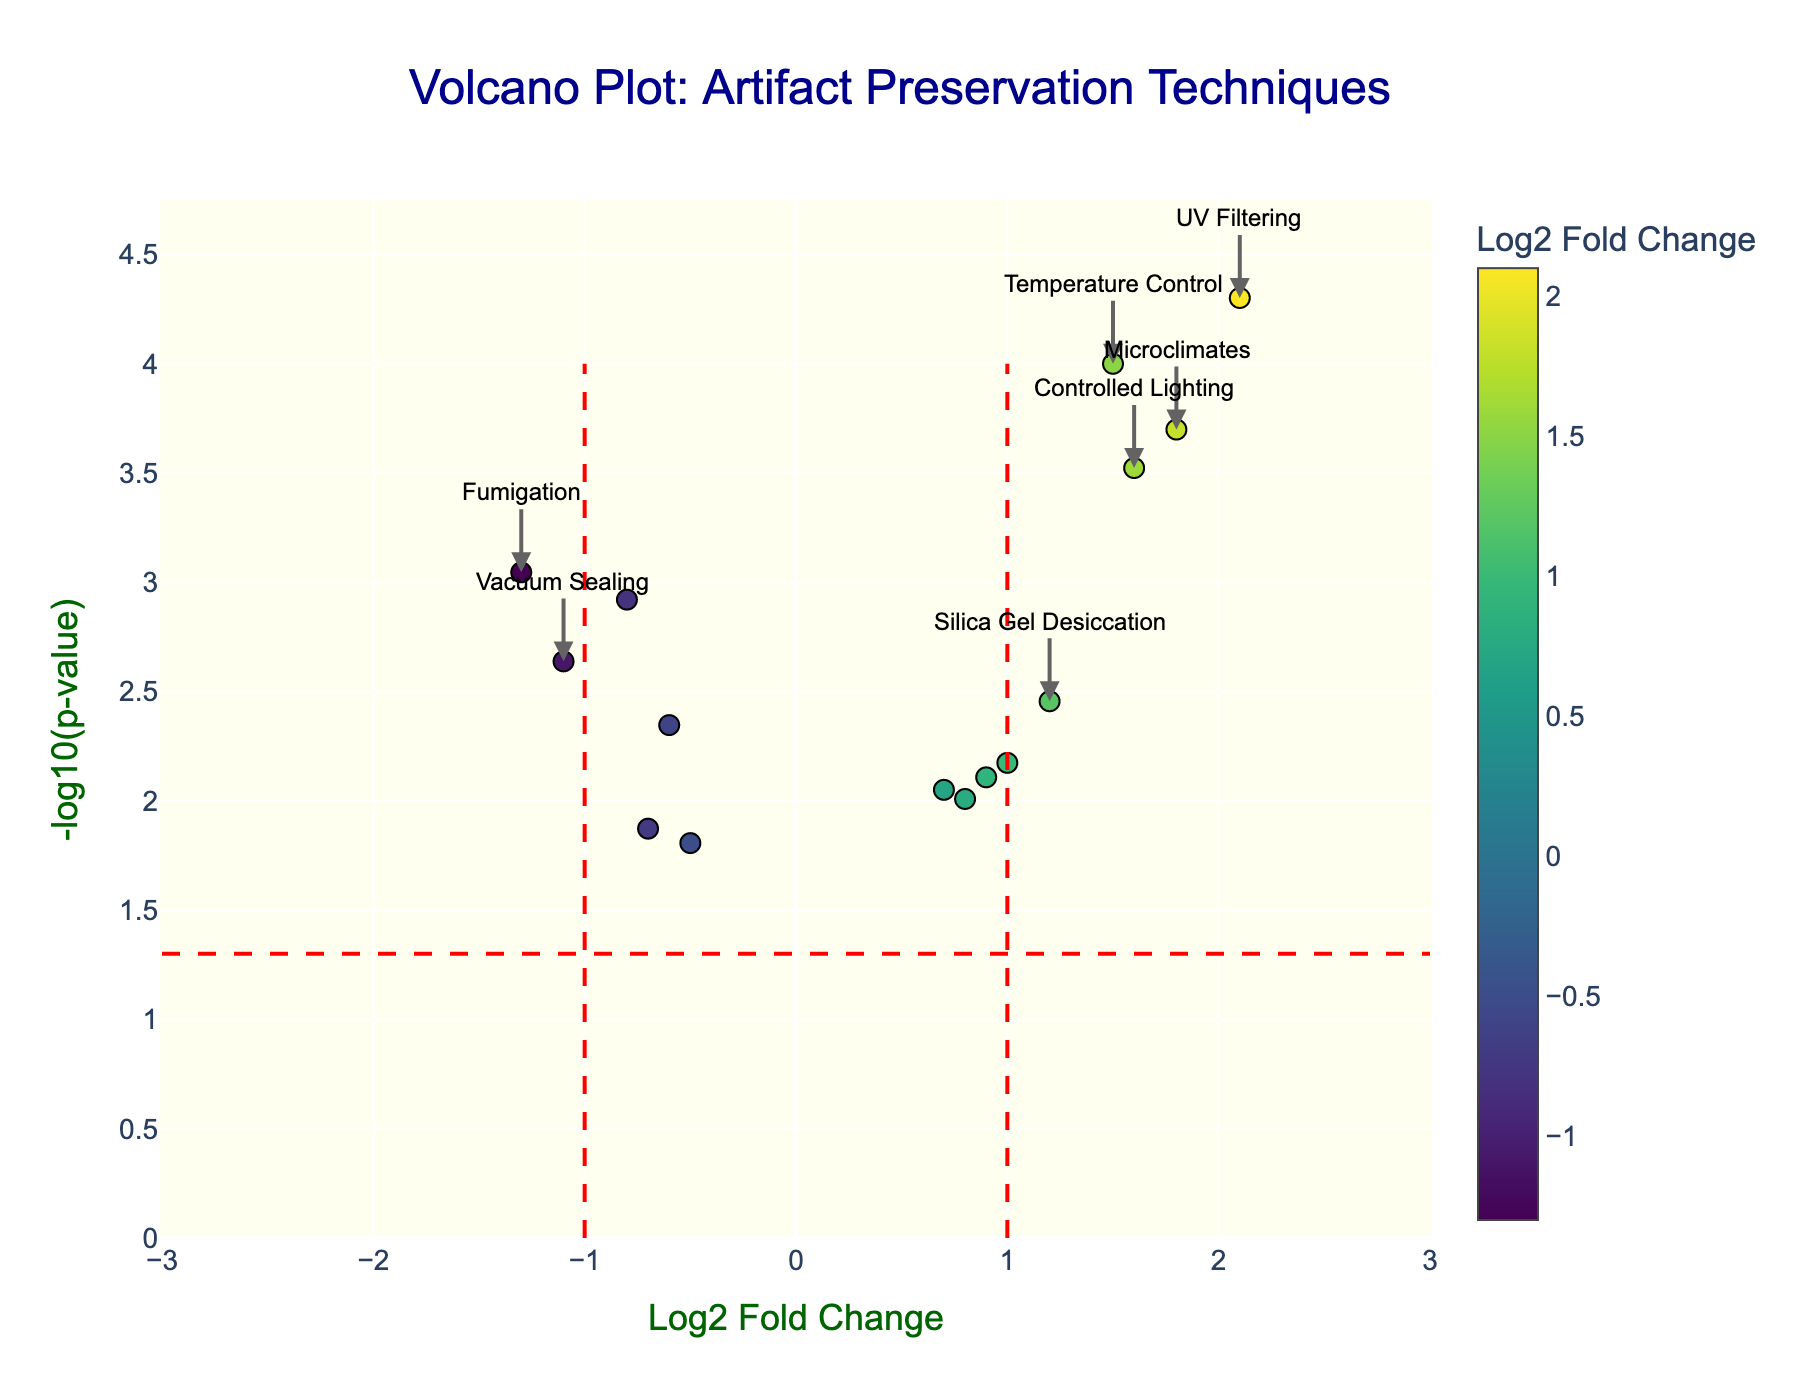What is the title of the plot? The title of the plot is usually displayed at the top of the figure in a larger and bold font. In this case, the title is 'Volcano Plot: Artifact Preservation Techniques' as shown at the center top.
Answer: Volcano Plot: Artifact Preservation Techniques How many data points (techniques) are plotted? By looking at the number of markers on the plot, you can count the total data points. In this plot, 15 techniques are represented by 15 markers.
Answer: 15 Which technique shows the highest log2 fold change? By identifying the data point that is farthest to the right on the x-axis, you can see that 'UV Filtering' has the highest log2 fold change of 2.1.
Answer: UV Filtering Which techniques are significantly improved according to the plot? Significant improvements are indicated by log2 fold change > 1 and p-value < 0.05 (above the threshold line). Techniques like 'Temperature Control' (1.5), 'Microclimates' (1.8), 'Controlled Lighting' (1.6), and 'UV Filtering' (2.1) meet these criteria.
Answer: Temperature Control, Microclimates, Controlled Lighting, UV Filtering How many techniques show a significant prevention of damage (i.e., negative significant log2 fold change)? To identify techniques with negative log2 fold change and p-value < 0.05, looking to the left of the plot's center divided by the red dashed line. Techniques like 'Anoxic Storage' (-0.8), 'Vacuum Sealing' (-1.1), and 'Fumigation' (-1.3) fall in this category.
Answer: 3 What are the p-values for the techniques that show a log2 fold change less than -1? The techniques 'Vacuum Sealing' and 'Fumigation' show a log2 fold change less than -1. Their corresponding p-values can be identified from the annotated text. 'Vacuum Sealing' has a p-value of 0.0023 and 'Fumigation' has a p-value of 0.0009.
Answer: 0.0023, 0.0009 Which technique has the least significant p-value and what is it? By identifying the technique furthest up the y-axis (-log10(p-value)), 'UV Filtering' has the least p-value of 0.00005.
Answer: UV Filtering, 0.00005 Is 'Silica Gel Desiccation' significantly different from other techniques? What does this indicate? 'Silica Gel Desiccation' is not significantly different as its log2 fold change is 1.2 and p-value is 0.0035, which does not meet the strict criteria of log2 fold change > ±1 and p-value < 0.05.
Answer: No, not significant Which techniques can be considered neither significantly improving nor deteriorating? Techniques with log2 fold change between -1 and 1, and p-value > 0.05 fall in this range. Examples: 'Acid-Free Packaging' (0.7), 'Freeze Drying' (-0.5), & 'Corrosion Inhibitors' (-0.7).
Answer: Acid-Free Packaging, Freeze Drying, Corrosion Inhibitors 